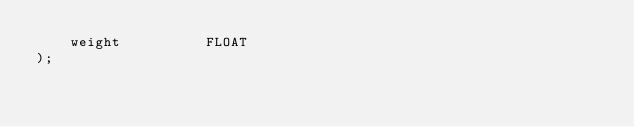<code> <loc_0><loc_0><loc_500><loc_500><_SQL_>    weight          FLOAT
);</code> 